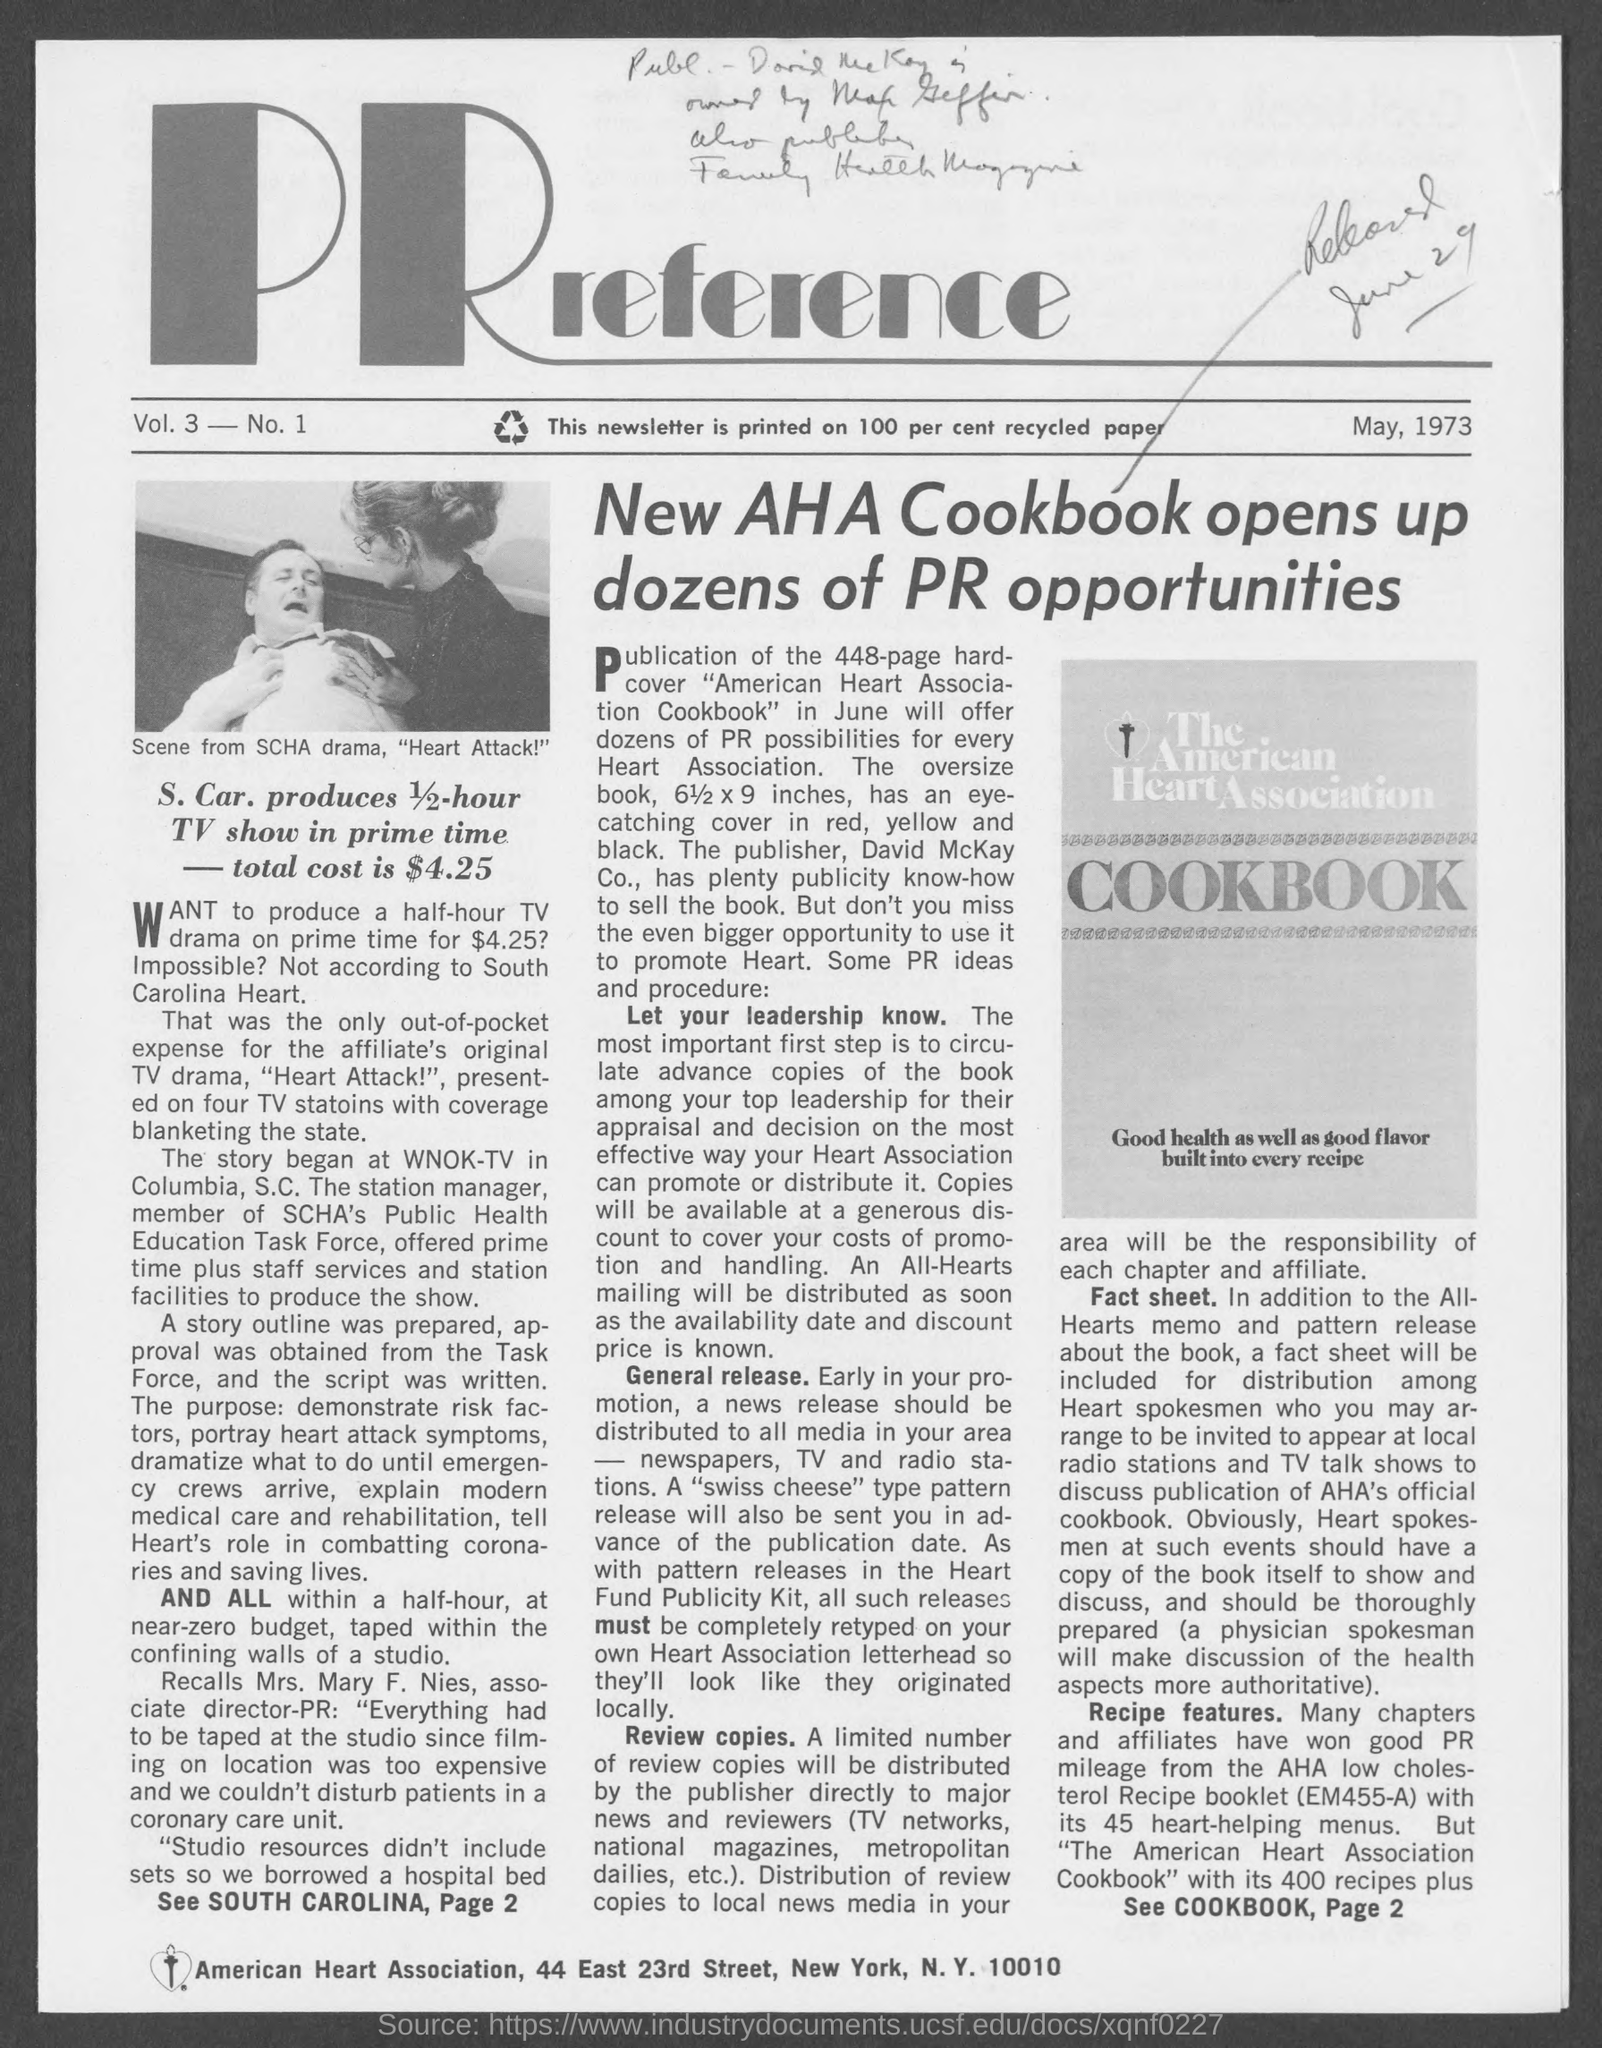What is the date mentioned in the given page ?
Offer a terse response. May, 1973. What is the total cost mentioned in the given page ?
Provide a short and direct response. $ 4.25. 